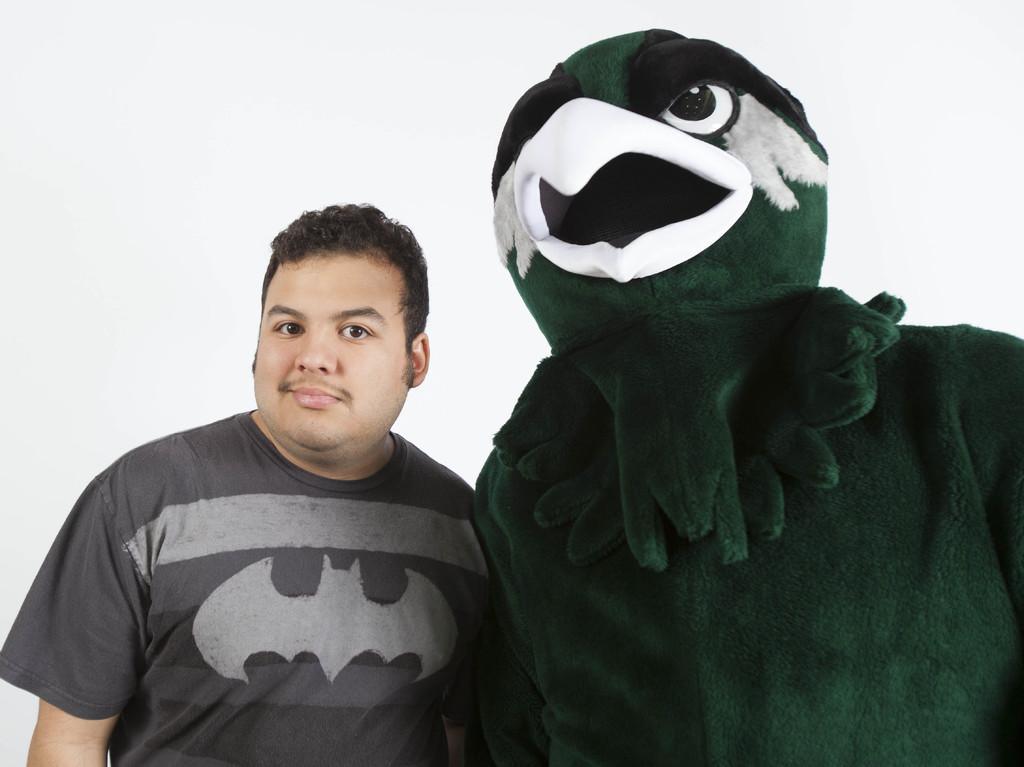Describe this image in one or two sentences. In this image there is one person standing on the right side is wearing a costume of a bird,and there is one another person standing on the left side to this person. 